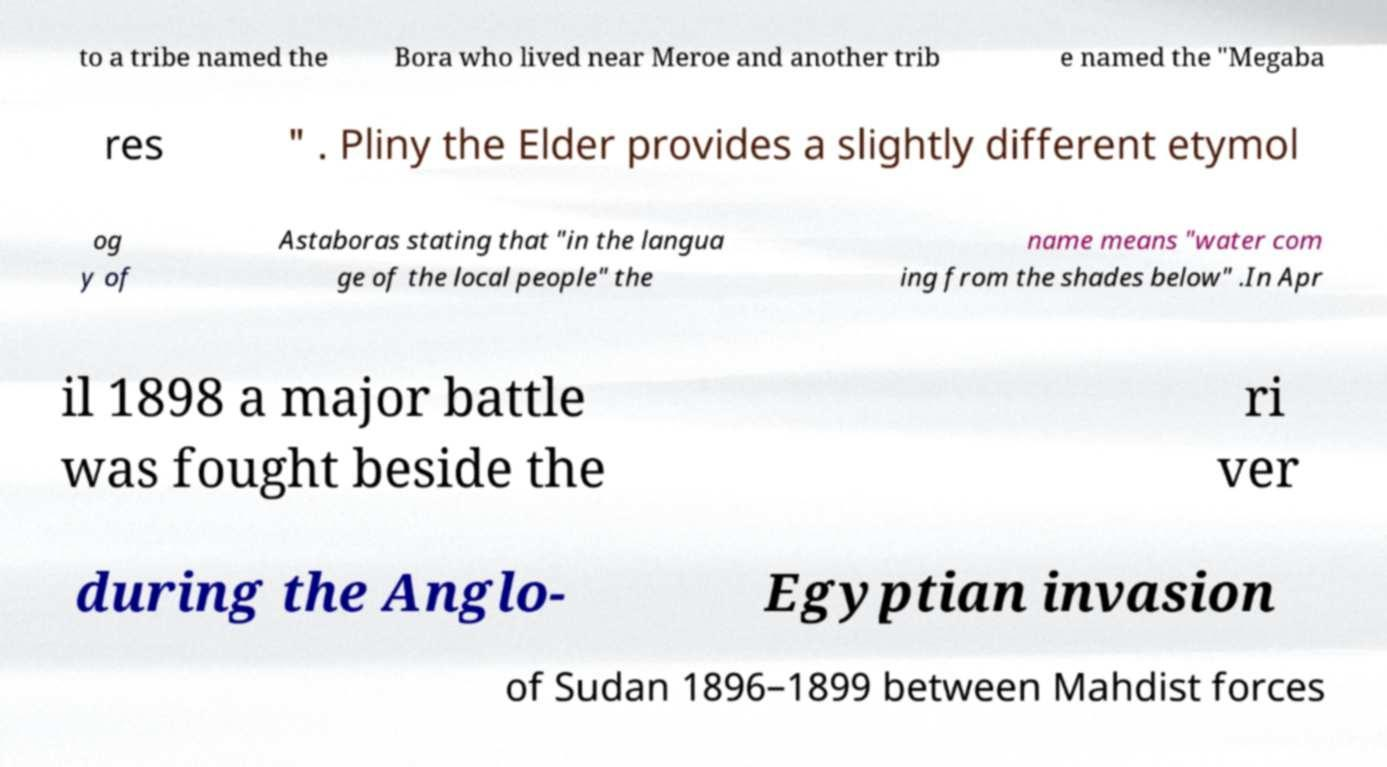There's text embedded in this image that I need extracted. Can you transcribe it verbatim? to a tribe named the Bora who lived near Meroe and another trib e named the "Megaba res " . Pliny the Elder provides a slightly different etymol og y of Astaboras stating that "in the langua ge of the local people" the name means "water com ing from the shades below" .In Apr il 1898 a major battle was fought beside the ri ver during the Anglo- Egyptian invasion of Sudan 1896–1899 between Mahdist forces 